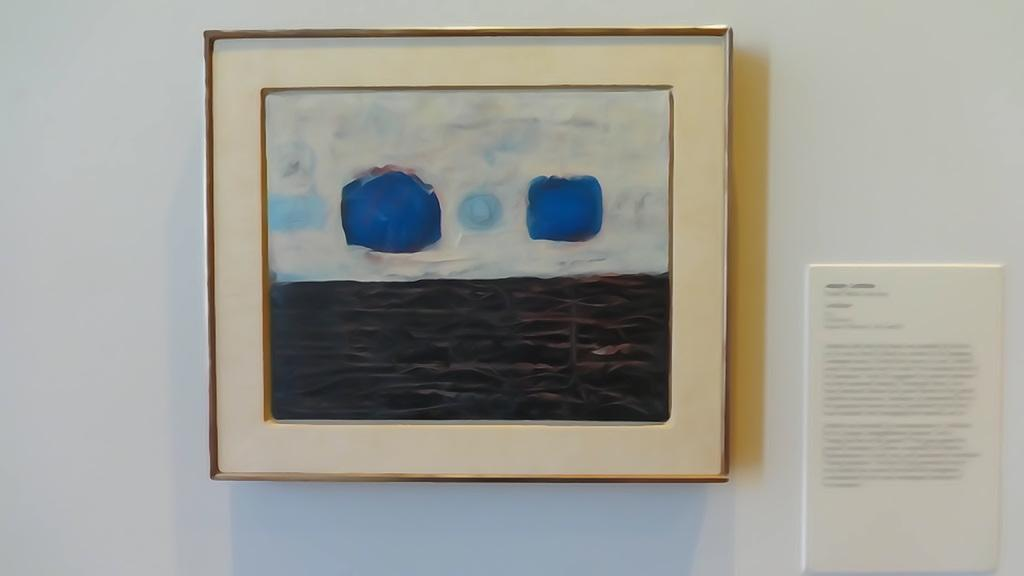What is the main object in the image? There is a frame in the image. What is attached to the wall in the image? There is a board on the wall in the image. What type of weather can be seen in the image? There is no weather visible in the image, as it only features a frame and a board on the wall. Can you hear a horn in the image? There is no horn present in the image, as it only features a frame and a board on the wall. 